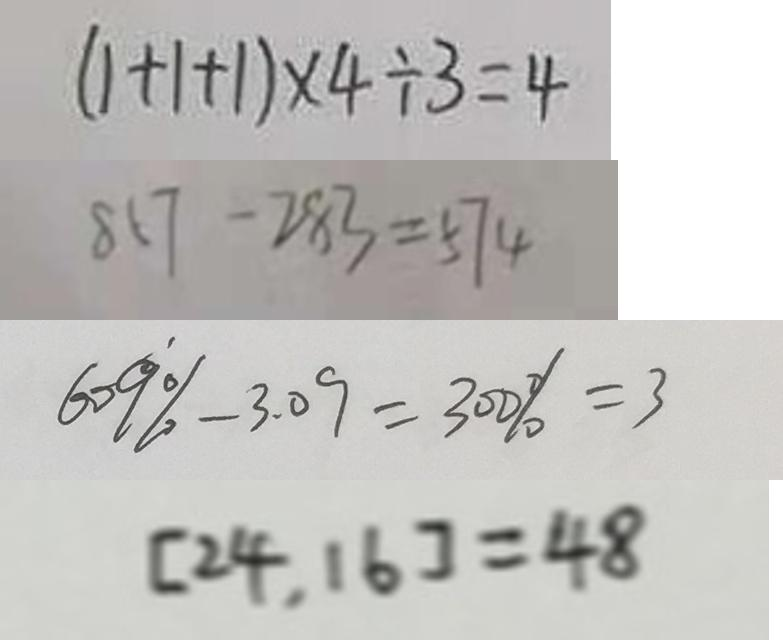<formula> <loc_0><loc_0><loc_500><loc_500>( 1 + 1 + 1 ) \times 4 \div 3 = 4 
 8 1 7 - 2 8 3 = 5 7 4 
 6 0 9 \% - 3 . 0 9 = 3 0 0 \% = 3 
 [ 2 4 , 1 6 ] = 4 8</formula> 